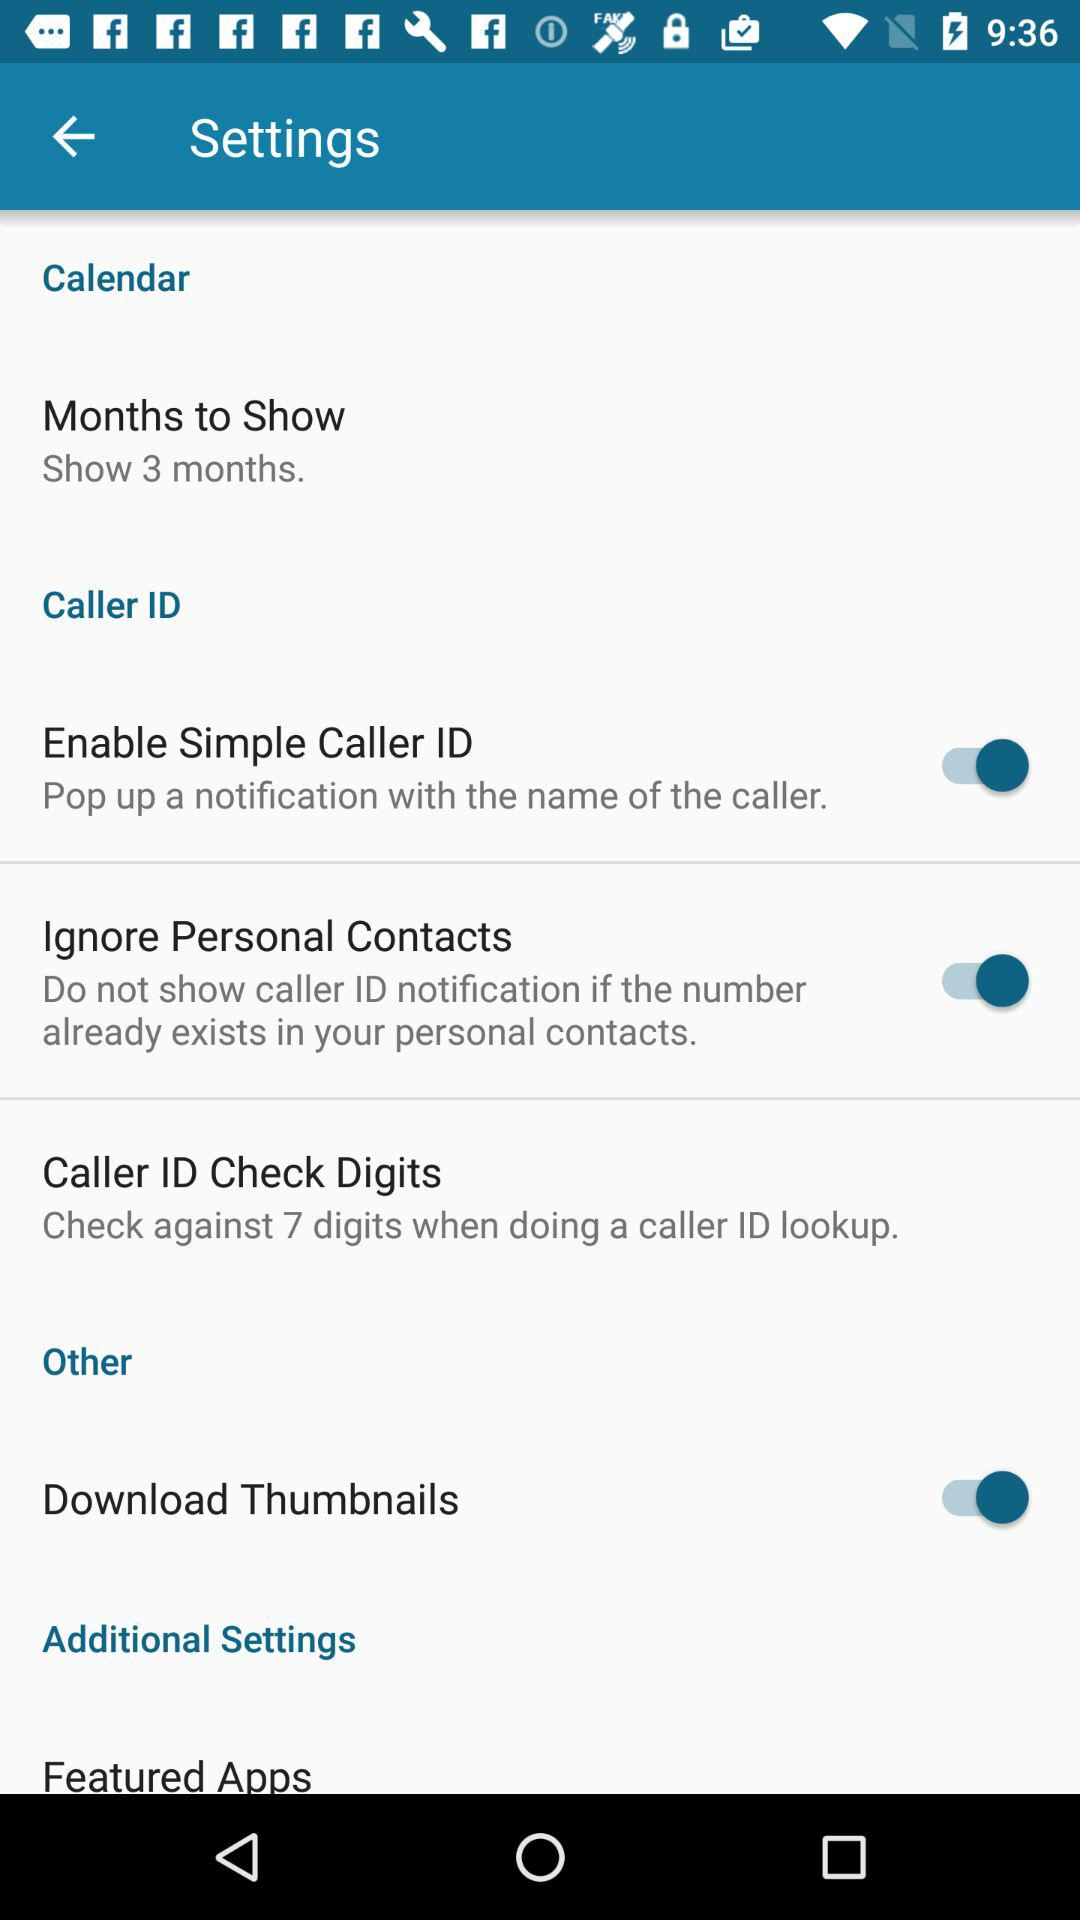What's the status of "Download Thumbnails"? The status is "on". 